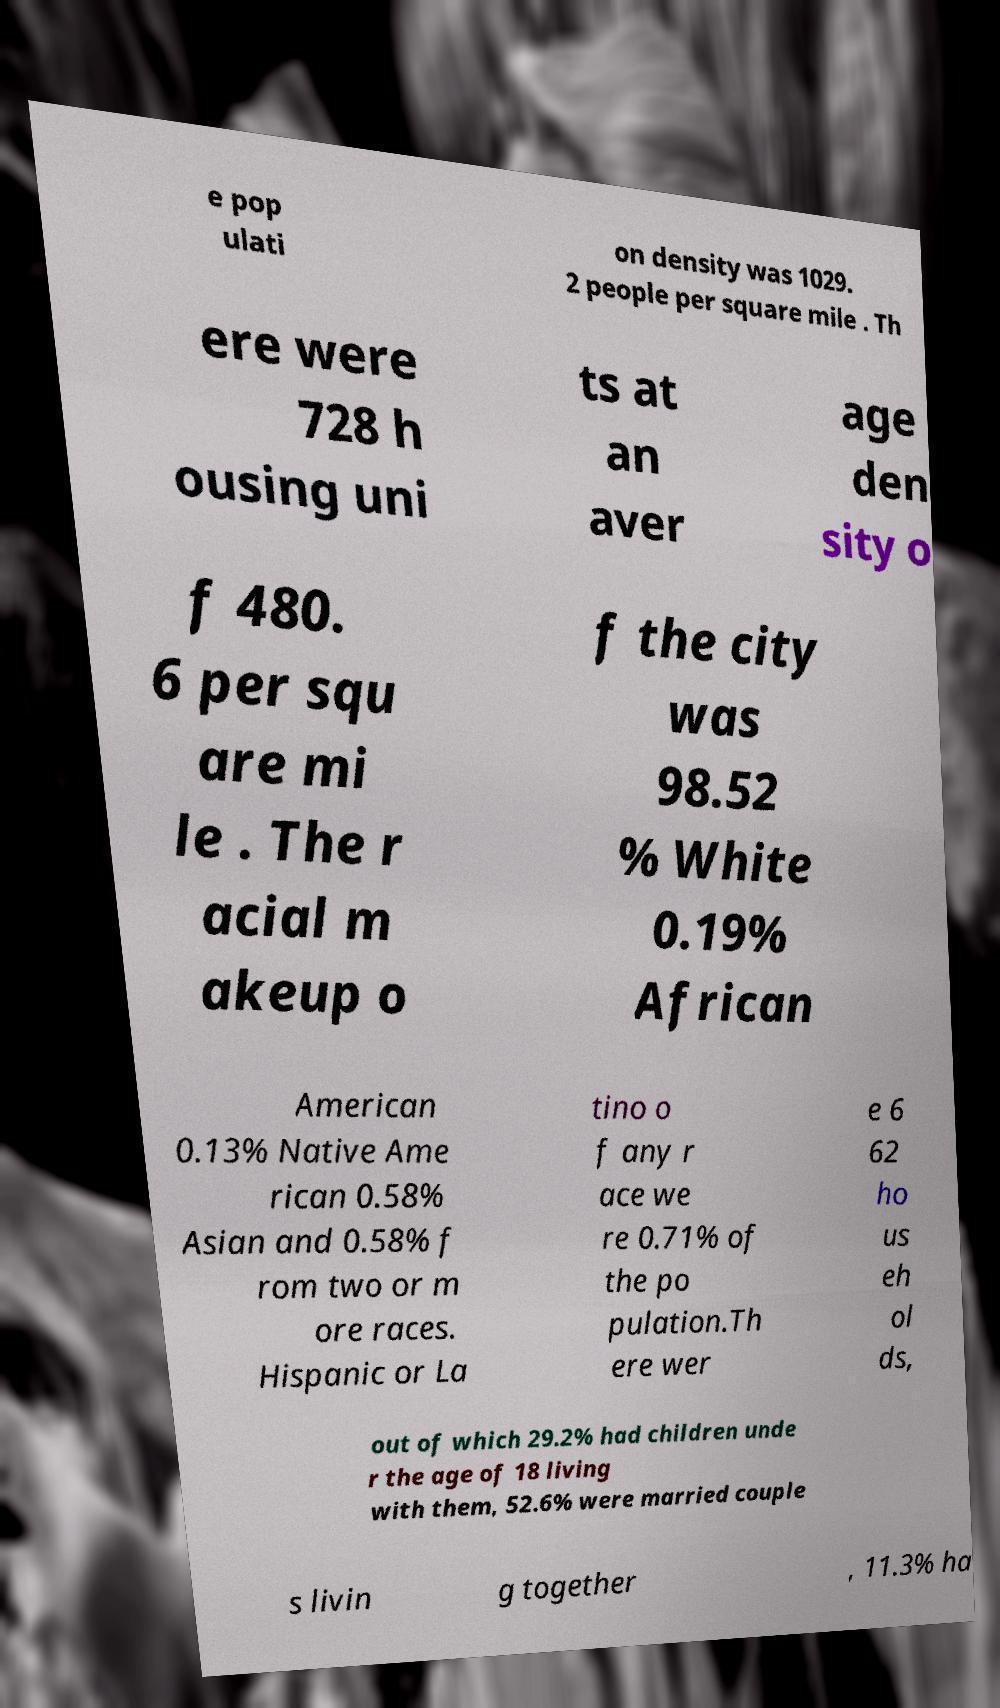Could you extract and type out the text from this image? e pop ulati on density was 1029. 2 people per square mile . Th ere were 728 h ousing uni ts at an aver age den sity o f 480. 6 per squ are mi le . The r acial m akeup o f the city was 98.52 % White 0.19% African American 0.13% Native Ame rican 0.58% Asian and 0.58% f rom two or m ore races. Hispanic or La tino o f any r ace we re 0.71% of the po pulation.Th ere wer e 6 62 ho us eh ol ds, out of which 29.2% had children unde r the age of 18 living with them, 52.6% were married couple s livin g together , 11.3% ha 